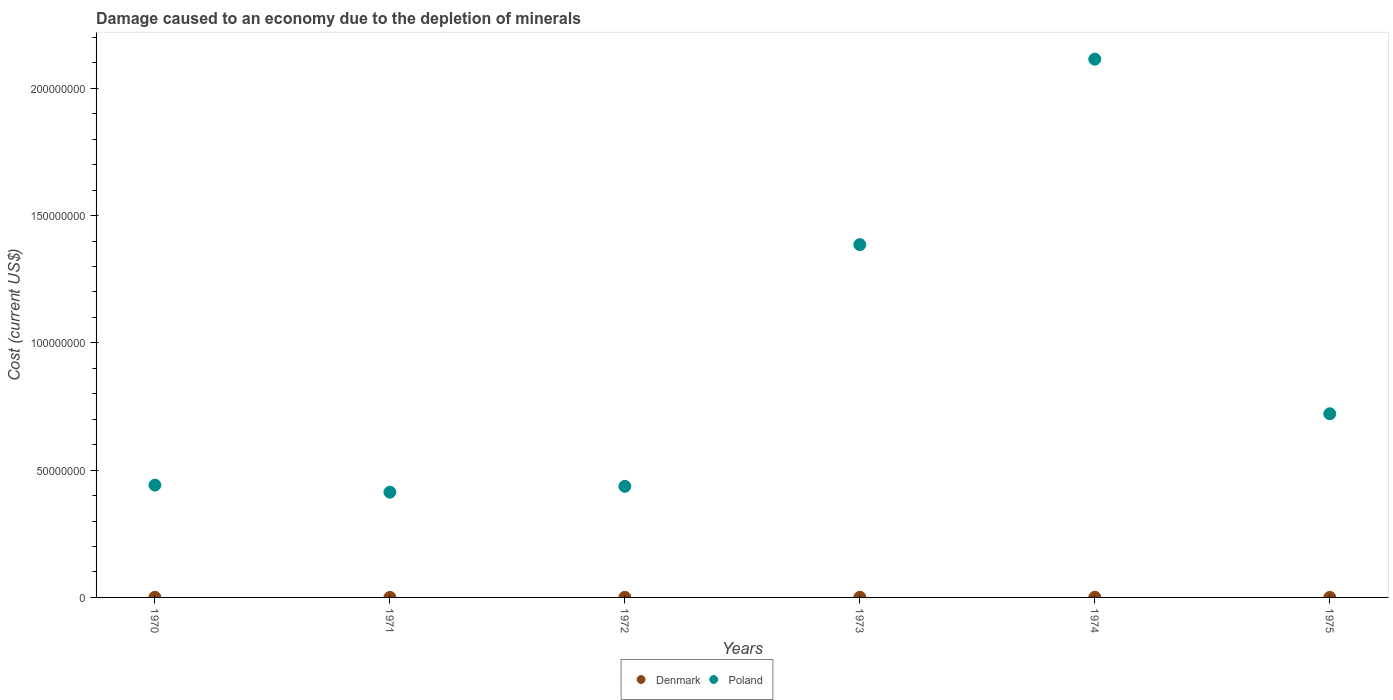Is the number of dotlines equal to the number of legend labels?
Offer a terse response. Yes. What is the cost of damage caused due to the depletion of minerals in Poland in 1970?
Keep it short and to the point. 4.41e+07. Across all years, what is the maximum cost of damage caused due to the depletion of minerals in Poland?
Give a very brief answer. 2.11e+08. Across all years, what is the minimum cost of damage caused due to the depletion of minerals in Poland?
Your answer should be very brief. 4.13e+07. In which year was the cost of damage caused due to the depletion of minerals in Poland maximum?
Your answer should be compact. 1974. What is the total cost of damage caused due to the depletion of minerals in Poland in the graph?
Provide a short and direct response. 5.51e+08. What is the difference between the cost of damage caused due to the depletion of minerals in Poland in 1971 and that in 1974?
Your response must be concise. -1.70e+08. What is the difference between the cost of damage caused due to the depletion of minerals in Denmark in 1973 and the cost of damage caused due to the depletion of minerals in Poland in 1974?
Your response must be concise. -2.11e+08. What is the average cost of damage caused due to the depletion of minerals in Poland per year?
Provide a short and direct response. 9.19e+07. In the year 1971, what is the difference between the cost of damage caused due to the depletion of minerals in Poland and cost of damage caused due to the depletion of minerals in Denmark?
Offer a terse response. 4.13e+07. What is the ratio of the cost of damage caused due to the depletion of minerals in Poland in 1970 to that in 1974?
Make the answer very short. 0.21. What is the difference between the highest and the second highest cost of damage caused due to the depletion of minerals in Denmark?
Ensure brevity in your answer.  1.62e+04. What is the difference between the highest and the lowest cost of damage caused due to the depletion of minerals in Poland?
Give a very brief answer. 1.70e+08. Is the sum of the cost of damage caused due to the depletion of minerals in Denmark in 1971 and 1975 greater than the maximum cost of damage caused due to the depletion of minerals in Poland across all years?
Your answer should be very brief. No. Does the cost of damage caused due to the depletion of minerals in Poland monotonically increase over the years?
Make the answer very short. No. Is the cost of damage caused due to the depletion of minerals in Poland strictly greater than the cost of damage caused due to the depletion of minerals in Denmark over the years?
Your answer should be very brief. Yes. Is the cost of damage caused due to the depletion of minerals in Poland strictly less than the cost of damage caused due to the depletion of minerals in Denmark over the years?
Give a very brief answer. No. How many dotlines are there?
Offer a very short reply. 2. What is the difference between two consecutive major ticks on the Y-axis?
Provide a succinct answer. 5.00e+07. Are the values on the major ticks of Y-axis written in scientific E-notation?
Your response must be concise. No. Does the graph contain any zero values?
Provide a succinct answer. No. Does the graph contain grids?
Keep it short and to the point. No. How are the legend labels stacked?
Offer a very short reply. Horizontal. What is the title of the graph?
Offer a very short reply. Damage caused to an economy due to the depletion of minerals. Does "OECD members" appear as one of the legend labels in the graph?
Provide a succinct answer. No. What is the label or title of the Y-axis?
Offer a terse response. Cost (current US$). What is the Cost (current US$) of Denmark in 1970?
Give a very brief answer. 4.32e+04. What is the Cost (current US$) in Poland in 1970?
Keep it short and to the point. 4.41e+07. What is the Cost (current US$) of Denmark in 1971?
Offer a terse response. 7188.58. What is the Cost (current US$) in Poland in 1971?
Keep it short and to the point. 4.13e+07. What is the Cost (current US$) of Denmark in 1972?
Your answer should be very brief. 4.53e+04. What is the Cost (current US$) in Poland in 1972?
Give a very brief answer. 4.36e+07. What is the Cost (current US$) of Denmark in 1973?
Your answer should be very brief. 5.65e+04. What is the Cost (current US$) in Poland in 1973?
Make the answer very short. 1.39e+08. What is the Cost (current US$) in Denmark in 1974?
Offer a very short reply. 7.27e+04. What is the Cost (current US$) in Poland in 1974?
Your response must be concise. 2.11e+08. What is the Cost (current US$) in Denmark in 1975?
Provide a short and direct response. 1.03e+04. What is the Cost (current US$) of Poland in 1975?
Offer a very short reply. 7.21e+07. Across all years, what is the maximum Cost (current US$) in Denmark?
Give a very brief answer. 7.27e+04. Across all years, what is the maximum Cost (current US$) of Poland?
Give a very brief answer. 2.11e+08. Across all years, what is the minimum Cost (current US$) of Denmark?
Provide a short and direct response. 7188.58. Across all years, what is the minimum Cost (current US$) in Poland?
Provide a short and direct response. 4.13e+07. What is the total Cost (current US$) of Denmark in the graph?
Keep it short and to the point. 2.35e+05. What is the total Cost (current US$) in Poland in the graph?
Give a very brief answer. 5.51e+08. What is the difference between the Cost (current US$) in Denmark in 1970 and that in 1971?
Ensure brevity in your answer.  3.60e+04. What is the difference between the Cost (current US$) in Poland in 1970 and that in 1971?
Provide a succinct answer. 2.79e+06. What is the difference between the Cost (current US$) of Denmark in 1970 and that in 1972?
Provide a short and direct response. -2100.47. What is the difference between the Cost (current US$) of Poland in 1970 and that in 1972?
Your answer should be very brief. 4.85e+05. What is the difference between the Cost (current US$) in Denmark in 1970 and that in 1973?
Your response must be concise. -1.32e+04. What is the difference between the Cost (current US$) of Poland in 1970 and that in 1973?
Keep it short and to the point. -9.45e+07. What is the difference between the Cost (current US$) of Denmark in 1970 and that in 1974?
Give a very brief answer. -2.94e+04. What is the difference between the Cost (current US$) in Poland in 1970 and that in 1974?
Provide a succinct answer. -1.67e+08. What is the difference between the Cost (current US$) of Denmark in 1970 and that in 1975?
Your answer should be compact. 3.29e+04. What is the difference between the Cost (current US$) in Poland in 1970 and that in 1975?
Offer a very short reply. -2.80e+07. What is the difference between the Cost (current US$) in Denmark in 1971 and that in 1972?
Provide a succinct answer. -3.81e+04. What is the difference between the Cost (current US$) of Poland in 1971 and that in 1972?
Your answer should be very brief. -2.31e+06. What is the difference between the Cost (current US$) in Denmark in 1971 and that in 1973?
Ensure brevity in your answer.  -4.93e+04. What is the difference between the Cost (current US$) in Poland in 1971 and that in 1973?
Your answer should be very brief. -9.73e+07. What is the difference between the Cost (current US$) in Denmark in 1971 and that in 1974?
Provide a succinct answer. -6.55e+04. What is the difference between the Cost (current US$) of Poland in 1971 and that in 1974?
Your response must be concise. -1.70e+08. What is the difference between the Cost (current US$) of Denmark in 1971 and that in 1975?
Offer a very short reply. -3101.62. What is the difference between the Cost (current US$) in Poland in 1971 and that in 1975?
Your answer should be compact. -3.08e+07. What is the difference between the Cost (current US$) of Denmark in 1972 and that in 1973?
Make the answer very short. -1.11e+04. What is the difference between the Cost (current US$) of Poland in 1972 and that in 1973?
Offer a very short reply. -9.50e+07. What is the difference between the Cost (current US$) in Denmark in 1972 and that in 1974?
Provide a succinct answer. -2.73e+04. What is the difference between the Cost (current US$) of Poland in 1972 and that in 1974?
Provide a succinct answer. -1.68e+08. What is the difference between the Cost (current US$) in Denmark in 1972 and that in 1975?
Ensure brevity in your answer.  3.50e+04. What is the difference between the Cost (current US$) of Poland in 1972 and that in 1975?
Your answer should be compact. -2.85e+07. What is the difference between the Cost (current US$) of Denmark in 1973 and that in 1974?
Ensure brevity in your answer.  -1.62e+04. What is the difference between the Cost (current US$) of Poland in 1973 and that in 1974?
Give a very brief answer. -7.29e+07. What is the difference between the Cost (current US$) of Denmark in 1973 and that in 1975?
Make the answer very short. 4.62e+04. What is the difference between the Cost (current US$) in Poland in 1973 and that in 1975?
Your answer should be very brief. 6.64e+07. What is the difference between the Cost (current US$) of Denmark in 1974 and that in 1975?
Your answer should be compact. 6.24e+04. What is the difference between the Cost (current US$) in Poland in 1974 and that in 1975?
Make the answer very short. 1.39e+08. What is the difference between the Cost (current US$) of Denmark in 1970 and the Cost (current US$) of Poland in 1971?
Keep it short and to the point. -4.13e+07. What is the difference between the Cost (current US$) of Denmark in 1970 and the Cost (current US$) of Poland in 1972?
Offer a very short reply. -4.36e+07. What is the difference between the Cost (current US$) in Denmark in 1970 and the Cost (current US$) in Poland in 1973?
Your answer should be very brief. -1.39e+08. What is the difference between the Cost (current US$) in Denmark in 1970 and the Cost (current US$) in Poland in 1974?
Ensure brevity in your answer.  -2.11e+08. What is the difference between the Cost (current US$) in Denmark in 1970 and the Cost (current US$) in Poland in 1975?
Give a very brief answer. -7.21e+07. What is the difference between the Cost (current US$) of Denmark in 1971 and the Cost (current US$) of Poland in 1972?
Ensure brevity in your answer.  -4.36e+07. What is the difference between the Cost (current US$) in Denmark in 1971 and the Cost (current US$) in Poland in 1973?
Offer a terse response. -1.39e+08. What is the difference between the Cost (current US$) in Denmark in 1971 and the Cost (current US$) in Poland in 1974?
Offer a very short reply. -2.11e+08. What is the difference between the Cost (current US$) in Denmark in 1971 and the Cost (current US$) in Poland in 1975?
Your response must be concise. -7.21e+07. What is the difference between the Cost (current US$) in Denmark in 1972 and the Cost (current US$) in Poland in 1973?
Ensure brevity in your answer.  -1.39e+08. What is the difference between the Cost (current US$) in Denmark in 1972 and the Cost (current US$) in Poland in 1974?
Provide a short and direct response. -2.11e+08. What is the difference between the Cost (current US$) of Denmark in 1972 and the Cost (current US$) of Poland in 1975?
Ensure brevity in your answer.  -7.21e+07. What is the difference between the Cost (current US$) of Denmark in 1973 and the Cost (current US$) of Poland in 1974?
Make the answer very short. -2.11e+08. What is the difference between the Cost (current US$) of Denmark in 1973 and the Cost (current US$) of Poland in 1975?
Make the answer very short. -7.21e+07. What is the difference between the Cost (current US$) in Denmark in 1974 and the Cost (current US$) in Poland in 1975?
Your answer should be very brief. -7.21e+07. What is the average Cost (current US$) of Denmark per year?
Ensure brevity in your answer.  3.92e+04. What is the average Cost (current US$) in Poland per year?
Offer a terse response. 9.19e+07. In the year 1970, what is the difference between the Cost (current US$) of Denmark and Cost (current US$) of Poland?
Keep it short and to the point. -4.41e+07. In the year 1971, what is the difference between the Cost (current US$) of Denmark and Cost (current US$) of Poland?
Offer a very short reply. -4.13e+07. In the year 1972, what is the difference between the Cost (current US$) in Denmark and Cost (current US$) in Poland?
Provide a short and direct response. -4.36e+07. In the year 1973, what is the difference between the Cost (current US$) in Denmark and Cost (current US$) in Poland?
Your answer should be compact. -1.39e+08. In the year 1974, what is the difference between the Cost (current US$) of Denmark and Cost (current US$) of Poland?
Offer a terse response. -2.11e+08. In the year 1975, what is the difference between the Cost (current US$) in Denmark and Cost (current US$) in Poland?
Provide a short and direct response. -7.21e+07. What is the ratio of the Cost (current US$) of Denmark in 1970 to that in 1971?
Your answer should be compact. 6.01. What is the ratio of the Cost (current US$) in Poland in 1970 to that in 1971?
Offer a very short reply. 1.07. What is the ratio of the Cost (current US$) of Denmark in 1970 to that in 1972?
Offer a terse response. 0.95. What is the ratio of the Cost (current US$) in Poland in 1970 to that in 1972?
Provide a short and direct response. 1.01. What is the ratio of the Cost (current US$) of Denmark in 1970 to that in 1973?
Give a very brief answer. 0.77. What is the ratio of the Cost (current US$) in Poland in 1970 to that in 1973?
Your answer should be compact. 0.32. What is the ratio of the Cost (current US$) of Denmark in 1970 to that in 1974?
Keep it short and to the point. 0.59. What is the ratio of the Cost (current US$) in Poland in 1970 to that in 1974?
Offer a terse response. 0.21. What is the ratio of the Cost (current US$) of Denmark in 1970 to that in 1975?
Your answer should be very brief. 4.2. What is the ratio of the Cost (current US$) of Poland in 1970 to that in 1975?
Keep it short and to the point. 0.61. What is the ratio of the Cost (current US$) of Denmark in 1971 to that in 1972?
Your answer should be compact. 0.16. What is the ratio of the Cost (current US$) in Poland in 1971 to that in 1972?
Your answer should be compact. 0.95. What is the ratio of the Cost (current US$) in Denmark in 1971 to that in 1973?
Keep it short and to the point. 0.13. What is the ratio of the Cost (current US$) of Poland in 1971 to that in 1973?
Your answer should be compact. 0.3. What is the ratio of the Cost (current US$) of Denmark in 1971 to that in 1974?
Your answer should be compact. 0.1. What is the ratio of the Cost (current US$) in Poland in 1971 to that in 1974?
Your answer should be very brief. 0.2. What is the ratio of the Cost (current US$) in Denmark in 1971 to that in 1975?
Your answer should be very brief. 0.7. What is the ratio of the Cost (current US$) in Poland in 1971 to that in 1975?
Your answer should be compact. 0.57. What is the ratio of the Cost (current US$) in Denmark in 1972 to that in 1973?
Offer a very short reply. 0.8. What is the ratio of the Cost (current US$) in Poland in 1972 to that in 1973?
Your response must be concise. 0.31. What is the ratio of the Cost (current US$) of Denmark in 1972 to that in 1974?
Offer a terse response. 0.62. What is the ratio of the Cost (current US$) in Poland in 1972 to that in 1974?
Provide a succinct answer. 0.21. What is the ratio of the Cost (current US$) of Denmark in 1972 to that in 1975?
Ensure brevity in your answer.  4.41. What is the ratio of the Cost (current US$) of Poland in 1972 to that in 1975?
Your answer should be compact. 0.6. What is the ratio of the Cost (current US$) of Denmark in 1973 to that in 1974?
Your answer should be compact. 0.78. What is the ratio of the Cost (current US$) in Poland in 1973 to that in 1974?
Give a very brief answer. 0.66. What is the ratio of the Cost (current US$) in Denmark in 1973 to that in 1975?
Make the answer very short. 5.49. What is the ratio of the Cost (current US$) of Poland in 1973 to that in 1975?
Your answer should be very brief. 1.92. What is the ratio of the Cost (current US$) in Denmark in 1974 to that in 1975?
Offer a terse response. 7.06. What is the ratio of the Cost (current US$) in Poland in 1974 to that in 1975?
Make the answer very short. 2.93. What is the difference between the highest and the second highest Cost (current US$) of Denmark?
Offer a very short reply. 1.62e+04. What is the difference between the highest and the second highest Cost (current US$) of Poland?
Your answer should be compact. 7.29e+07. What is the difference between the highest and the lowest Cost (current US$) in Denmark?
Provide a short and direct response. 6.55e+04. What is the difference between the highest and the lowest Cost (current US$) in Poland?
Your response must be concise. 1.70e+08. 